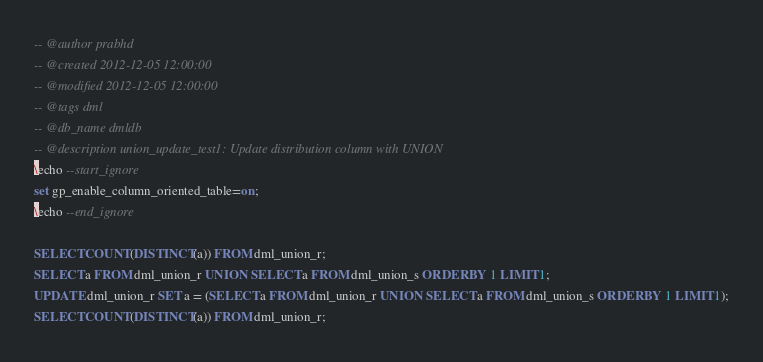<code> <loc_0><loc_0><loc_500><loc_500><_SQL_>-- @author prabhd 
-- @created 2012-12-05 12:00:00 
-- @modified 2012-12-05 12:00:00 
-- @tags dml 
-- @db_name dmldb
-- @description union_update_test1: Update distribution column with UNION
\echo --start_ignore
set gp_enable_column_oriented_table=on;
\echo --end_ignore

SELECT COUNT(DISTINCT(a)) FROM dml_union_r;
SELECT a FROM dml_union_r UNION SELECT a FROM dml_union_s ORDER BY 1 LIMIT 1;
UPDATE dml_union_r SET a = (SELECT a FROM dml_union_r UNION SELECT a FROM dml_union_s ORDER BY 1 LIMIT 1);
SELECT COUNT(DISTINCT(a)) FROM dml_union_r;
</code> 